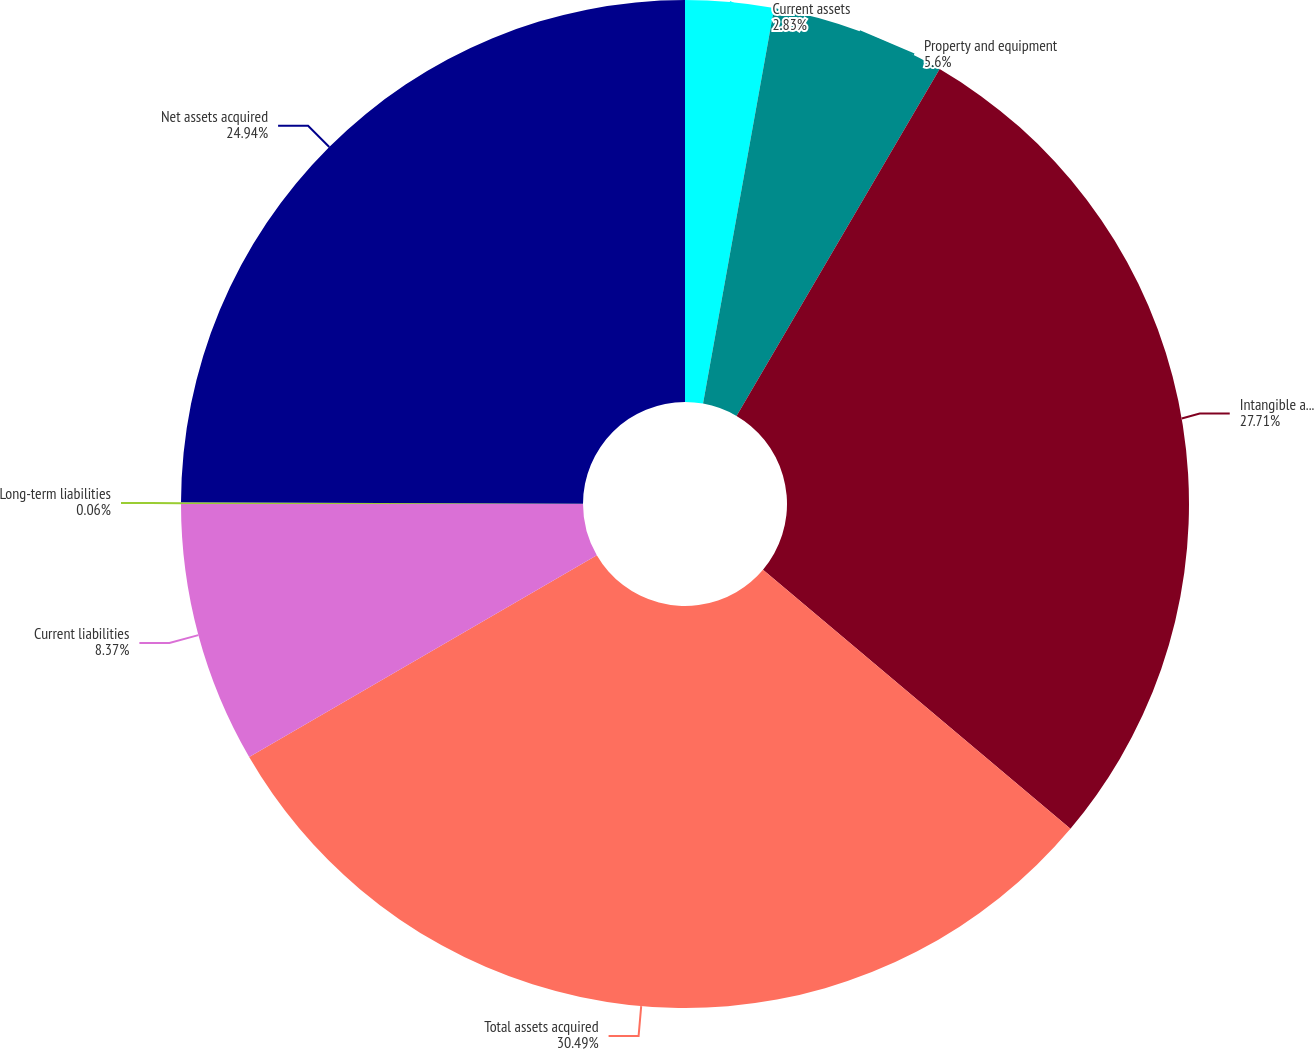Convert chart to OTSL. <chart><loc_0><loc_0><loc_500><loc_500><pie_chart><fcel>Current assets<fcel>Property and equipment<fcel>Intangible assets<fcel>Total assets acquired<fcel>Current liabilities<fcel>Long-term liabilities<fcel>Net assets acquired<nl><fcel>2.83%<fcel>5.6%<fcel>27.71%<fcel>30.48%<fcel>8.37%<fcel>0.06%<fcel>24.94%<nl></chart> 